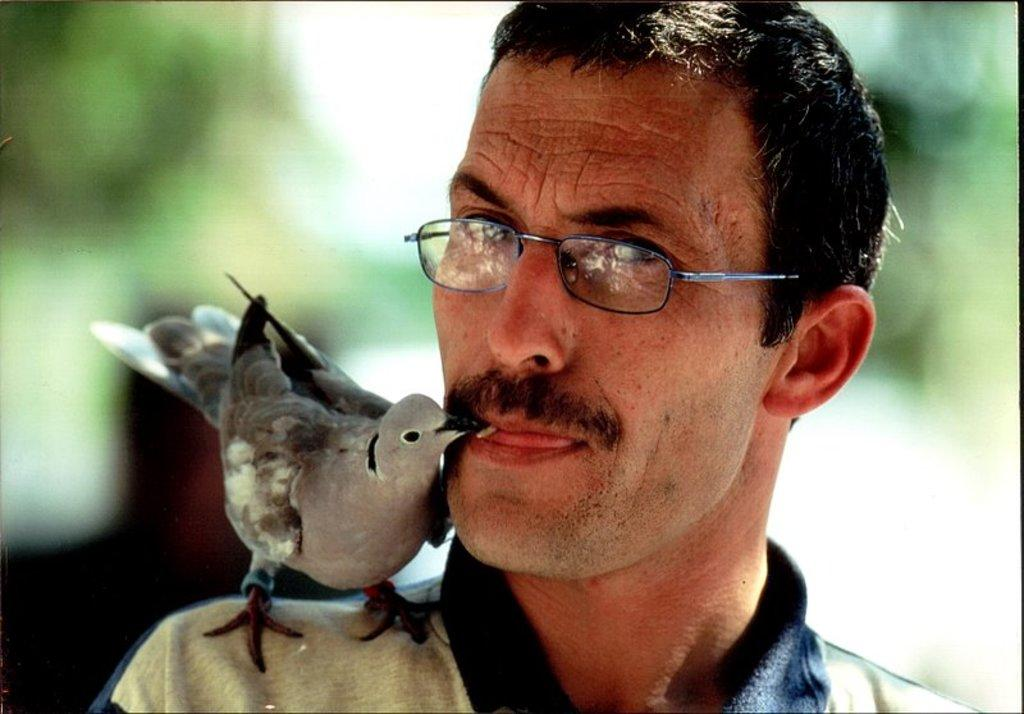What is on the person in the image? There is a bird on the person in the image. What is the person wearing? The person is wearing clothes and spectacles. How would you describe the background of the image? The background of the image is blurred. Can you see any goldfish swimming in the image? There are no goldfish present in the image. What type of brush is being used by the person in the image? There is no brush visible in the image. 